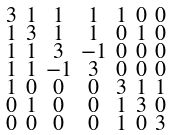Convert formula to latex. <formula><loc_0><loc_0><loc_500><loc_500>\begin{smallmatrix} 3 & 1 & 1 & 1 & 1 & 0 & 0 \\ 1 & 3 & 1 & 1 & 0 & 1 & 0 \\ 1 & 1 & 3 & - 1 & 0 & 0 & 0 \\ 1 & 1 & - 1 & 3 & 0 & 0 & 0 \\ 1 & 0 & 0 & 0 & 3 & 1 & 1 \\ 0 & 1 & 0 & 0 & 1 & 3 & 0 \\ 0 & 0 & 0 & 0 & 1 & 0 & 3 \end{smallmatrix}</formula> 